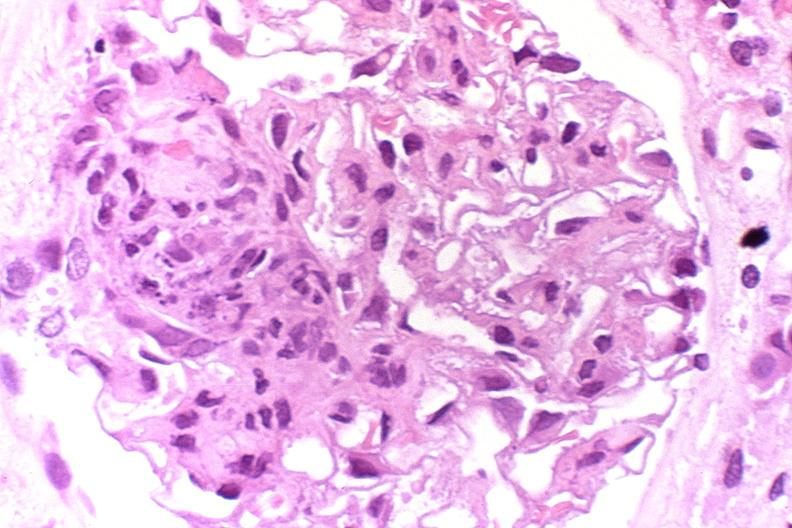does hypopharyngeal edema show glomerulonephritis, sle iii?
Answer the question using a single word or phrase. No 